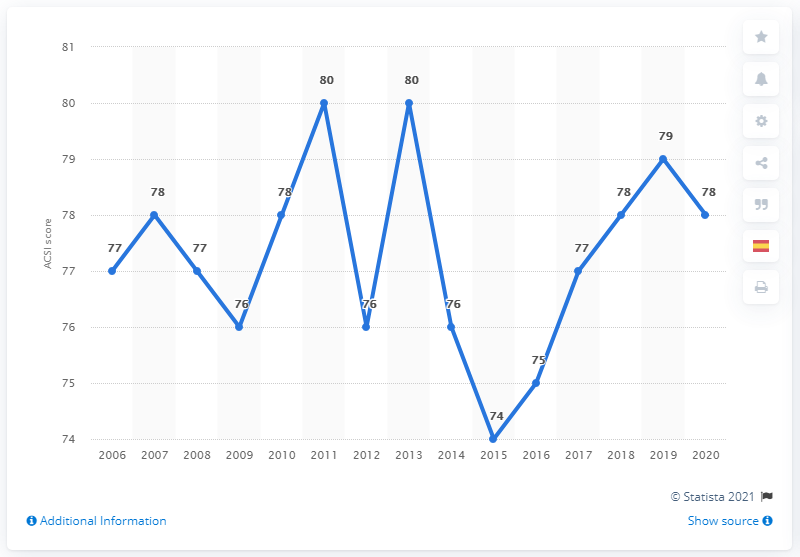What was Starbucks' ACSI score in 2020? In 2020, Starbucks received an American Customer Satisfaction Index (ACSI) score of 78. This score reflects customer satisfaction with their experience at Starbucks, which ranges from the quality of the beverages to the service provided. 